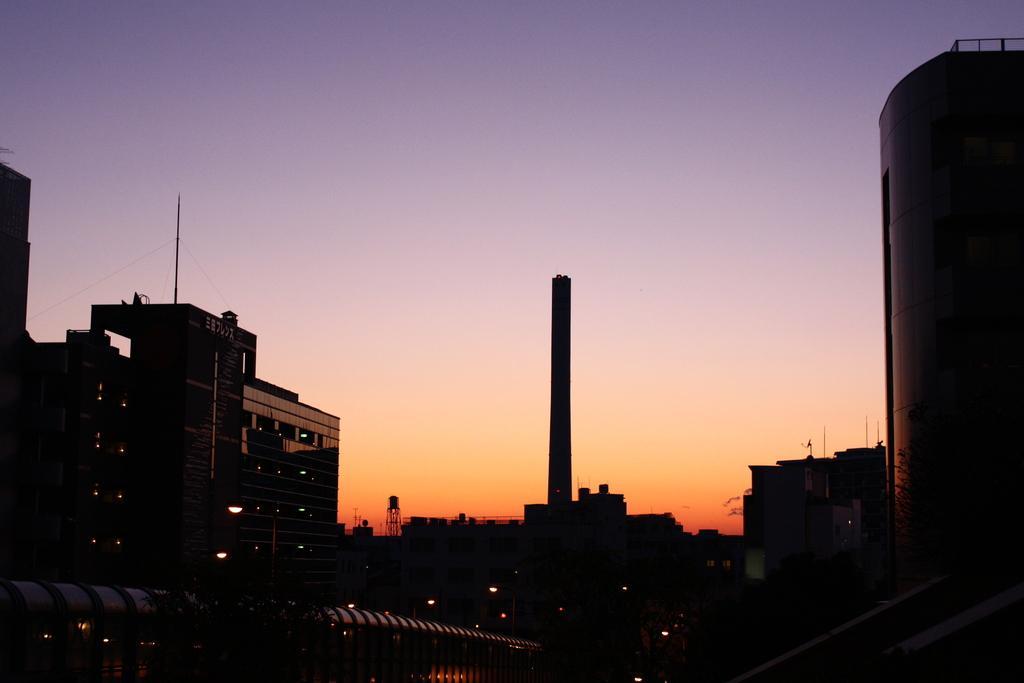How would you summarize this image in a sentence or two? In this image, we can see some buildings. There is a sky at the top of the image. There is a tower in the middle of the image. 